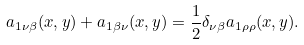<formula> <loc_0><loc_0><loc_500><loc_500>a _ { 1 \nu \beta } ( x , y ) + a _ { 1 \beta \nu } ( x , y ) = \frac { 1 } { 2 } \delta _ { \nu \beta } a _ { 1 \rho \rho } ( x , y ) .</formula> 